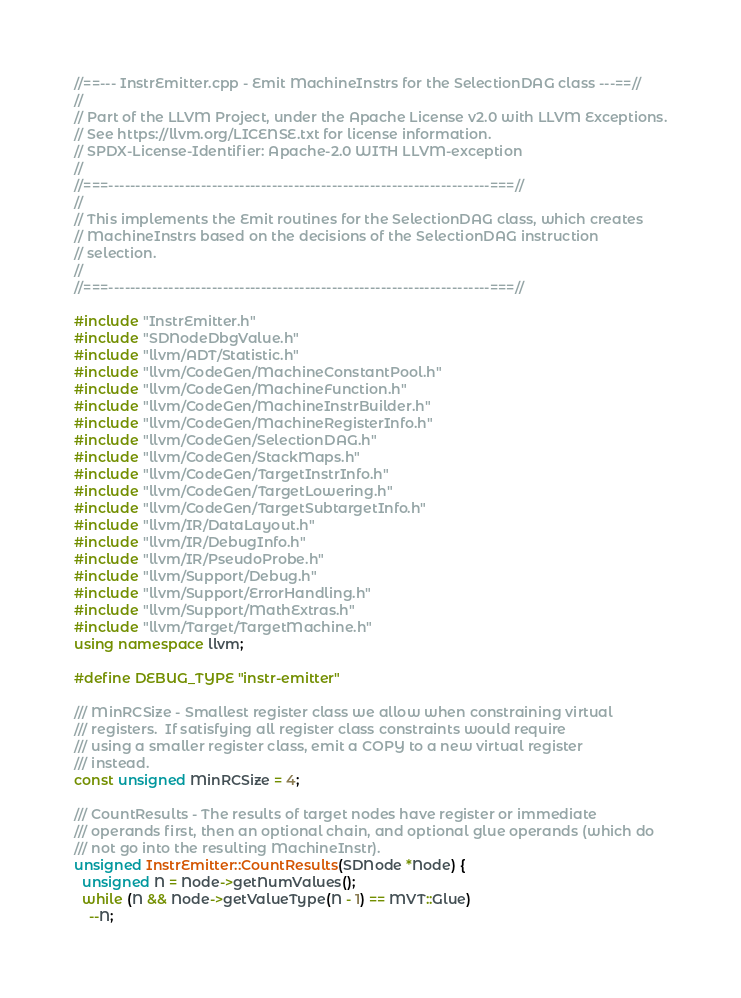Convert code to text. <code><loc_0><loc_0><loc_500><loc_500><_C++_>//==--- InstrEmitter.cpp - Emit MachineInstrs for the SelectionDAG class ---==//
//
// Part of the LLVM Project, under the Apache License v2.0 with LLVM Exceptions.
// See https://llvm.org/LICENSE.txt for license information.
// SPDX-License-Identifier: Apache-2.0 WITH LLVM-exception
//
//===----------------------------------------------------------------------===//
//
// This implements the Emit routines for the SelectionDAG class, which creates
// MachineInstrs based on the decisions of the SelectionDAG instruction
// selection.
//
//===----------------------------------------------------------------------===//

#include "InstrEmitter.h"
#include "SDNodeDbgValue.h"
#include "llvm/ADT/Statistic.h"
#include "llvm/CodeGen/MachineConstantPool.h"
#include "llvm/CodeGen/MachineFunction.h"
#include "llvm/CodeGen/MachineInstrBuilder.h"
#include "llvm/CodeGen/MachineRegisterInfo.h"
#include "llvm/CodeGen/SelectionDAG.h"
#include "llvm/CodeGen/StackMaps.h"
#include "llvm/CodeGen/TargetInstrInfo.h"
#include "llvm/CodeGen/TargetLowering.h"
#include "llvm/CodeGen/TargetSubtargetInfo.h"
#include "llvm/IR/DataLayout.h"
#include "llvm/IR/DebugInfo.h"
#include "llvm/IR/PseudoProbe.h"
#include "llvm/Support/Debug.h"
#include "llvm/Support/ErrorHandling.h"
#include "llvm/Support/MathExtras.h"
#include "llvm/Target/TargetMachine.h"
using namespace llvm;

#define DEBUG_TYPE "instr-emitter"

/// MinRCSize - Smallest register class we allow when constraining virtual
/// registers.  If satisfying all register class constraints would require
/// using a smaller register class, emit a COPY to a new virtual register
/// instead.
const unsigned MinRCSize = 4;

/// CountResults - The results of target nodes have register or immediate
/// operands first, then an optional chain, and optional glue operands (which do
/// not go into the resulting MachineInstr).
unsigned InstrEmitter::CountResults(SDNode *Node) {
  unsigned N = Node->getNumValues();
  while (N && Node->getValueType(N - 1) == MVT::Glue)
    --N;</code> 